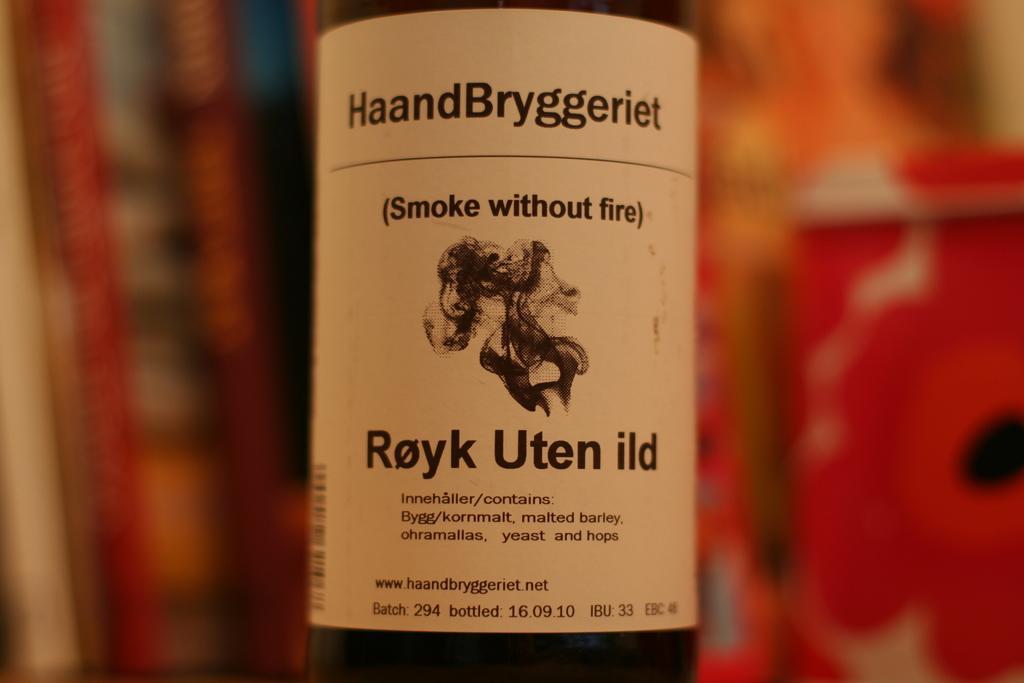Could you give a brief overview of what you see in this image? In this image we can see a bottle and label is attached to the bottle. 